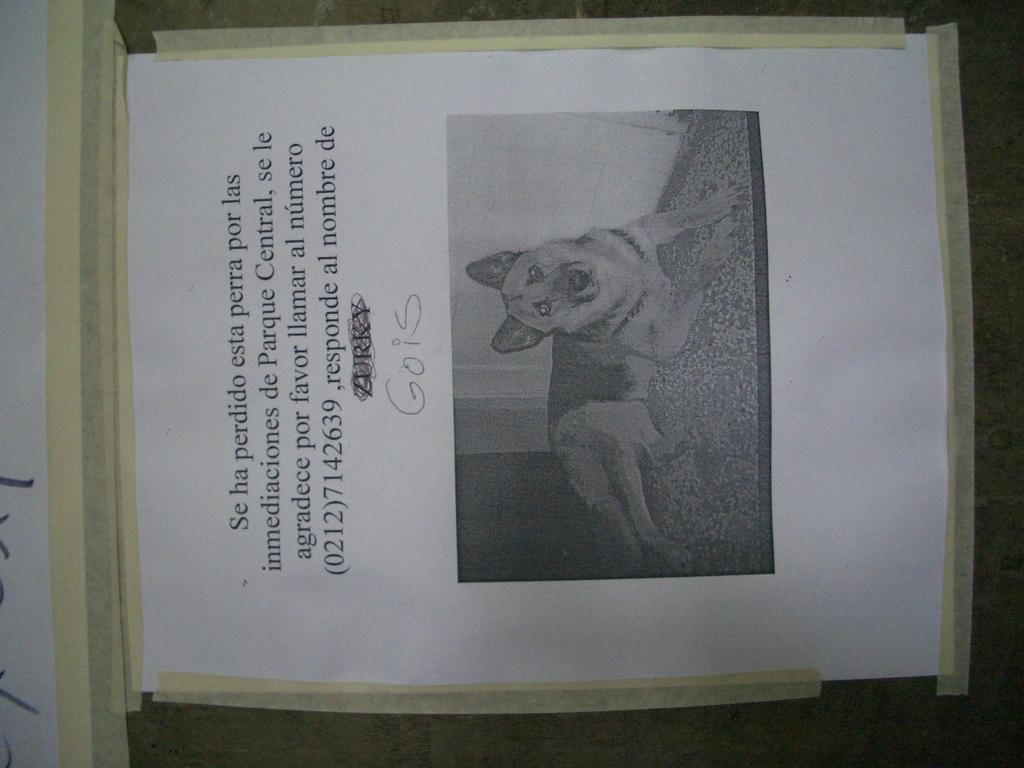Could you give a brief overview of what you see in this image? In this image I can see a board and a paper attached to the board. On the paper I can see the picture of a dog lying on the floor and something is written on the paper. 